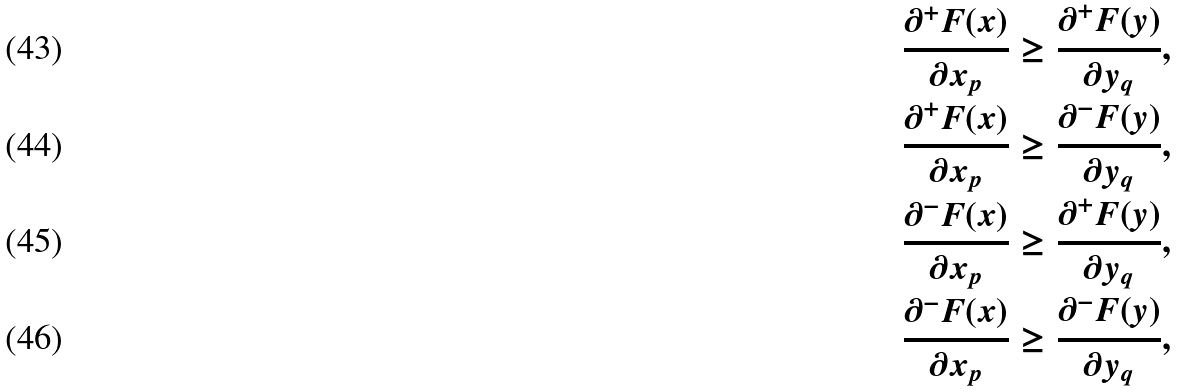Convert formula to latex. <formula><loc_0><loc_0><loc_500><loc_500>& \frac { \partial ^ { + } F ( x ) } { \partial x _ { p } } \geq \frac { \partial ^ { + } F ( y ) } { \partial y _ { q } } , \\ & \frac { \partial ^ { + } F ( x ) } { \partial x _ { p } } \geq \frac { \partial ^ { - } F ( y ) } { \partial y _ { q } } , \\ & \frac { \partial ^ { - } F ( x ) } { \partial x _ { p } } \geq \frac { \partial ^ { + } F ( y ) } { \partial y _ { q } } , \\ & \frac { \partial ^ { - } F ( x ) } { \partial x _ { p } } \geq \frac { \partial ^ { - } F ( y ) } { \partial y _ { q } } ,</formula> 